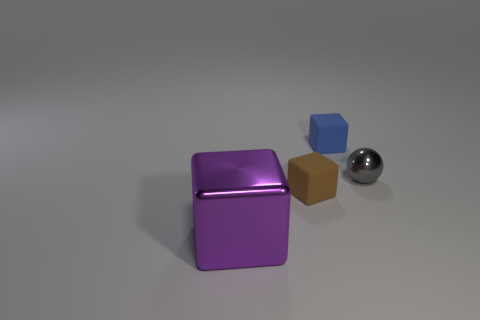There is a ball that is the same material as the big object; what size is it?
Ensure brevity in your answer.  Small. There is a tiny thing behind the metallic thing behind the purple cube; what number of brown things are in front of it?
Provide a short and direct response. 1. Do the small metallic ball and the small block behind the tiny brown matte block have the same color?
Your answer should be very brief. No. What material is the small block that is right of the small object that is left of the cube that is behind the tiny brown object made of?
Provide a short and direct response. Rubber. Does the tiny thing that is right of the small blue block have the same shape as the brown matte thing?
Offer a very short reply. No. There is a tiny block behind the tiny sphere; what is it made of?
Make the answer very short. Rubber. What number of metallic objects are purple things or tiny brown blocks?
Give a very brief answer. 1. Are there any gray spheres that have the same size as the brown rubber block?
Your response must be concise. Yes. Are there more metallic blocks right of the small metal sphere than small blocks?
Offer a very short reply. No. How many big objects are either rubber cubes or metallic balls?
Offer a terse response. 0. 